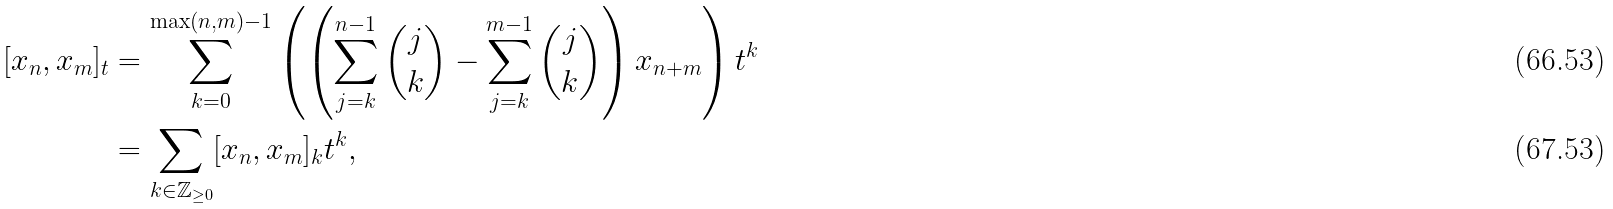Convert formula to latex. <formula><loc_0><loc_0><loc_500><loc_500>[ x _ { n } , x _ { m } ] _ { t } & = \sum _ { k = 0 } ^ { \max ( n , m ) - 1 } \left ( \left ( \sum _ { j = k } ^ { n - 1 } \binom { j } { k } - \sum _ { j = k } ^ { m - 1 } \binom { j } { k } \right ) x _ { n + m } \right ) t ^ { k } \\ & = \sum _ { k \in \mathbb { Z } _ { \geq 0 } } [ x _ { n } , x _ { m } ] _ { k } t ^ { k } ,</formula> 